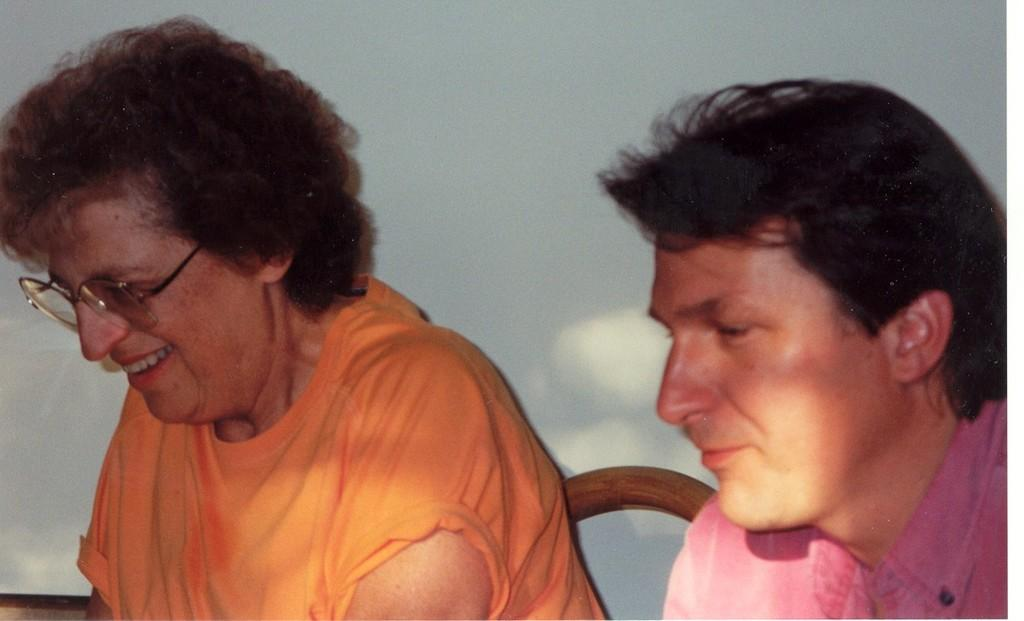How many people are in the image? There are two persons in the image. What are the persons doing in the image? The persons are sitting on chairs. Can you describe the facial expression of one of the persons? One of the persons is smiling. What is visible behind the persons? There is a wall behind the persons. What type of home is visible in the image? There is no specific type of home visible in the image; it only shows two persons sitting on chairs with a wall behind them. How many carriages are present in the image? There are no carriages present in the image. 